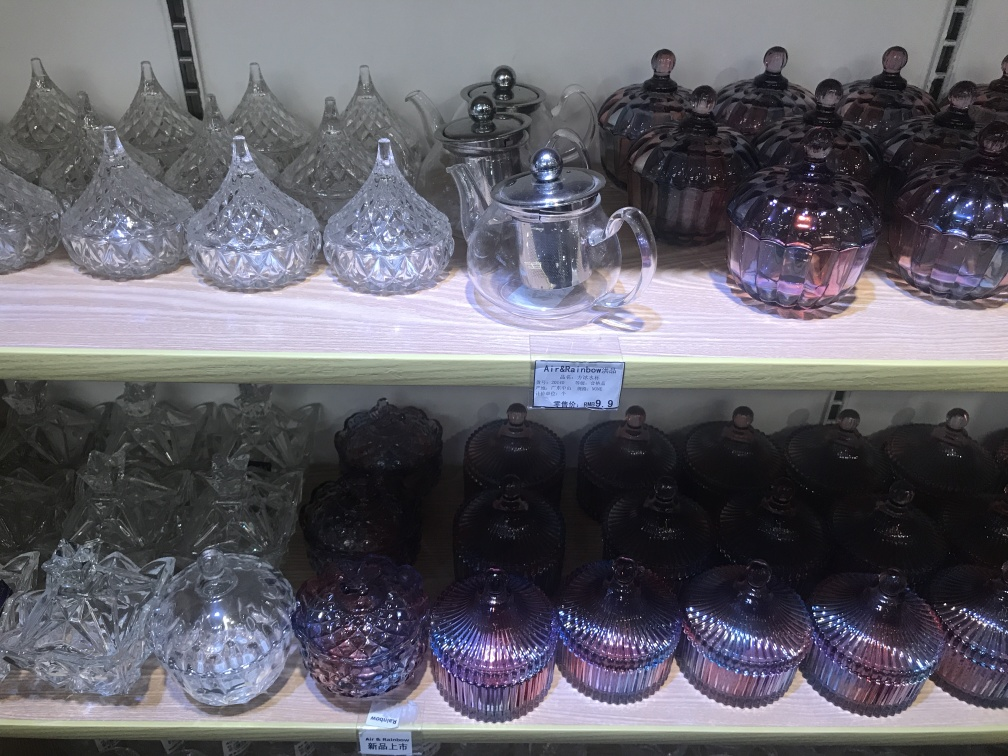Are the items in the image used for decoration or practical purposes? It is likely that the items serve both decorative and practical purposes. The clear and tinted glassware pieces, such as the teapot and patterned containers, could be used to serve beverages or store items while also acting as attractive decor due to their ornate designs and aesthetic appeal. 